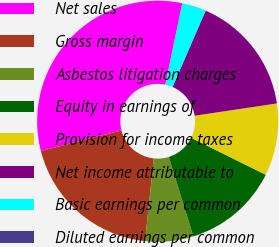Convert chart. <chart><loc_0><loc_0><loc_500><loc_500><pie_chart><fcel>Net sales<fcel>Gross margin<fcel>Asbestos litigation charges<fcel>Equity in earnings of<fcel>Provision for income taxes<fcel>Net income attributable to<fcel>Basic earnings per common<fcel>Diluted earnings per common<nl><fcel>32.25%<fcel>19.35%<fcel>6.46%<fcel>12.9%<fcel>9.68%<fcel>16.13%<fcel>3.23%<fcel>0.01%<nl></chart> 